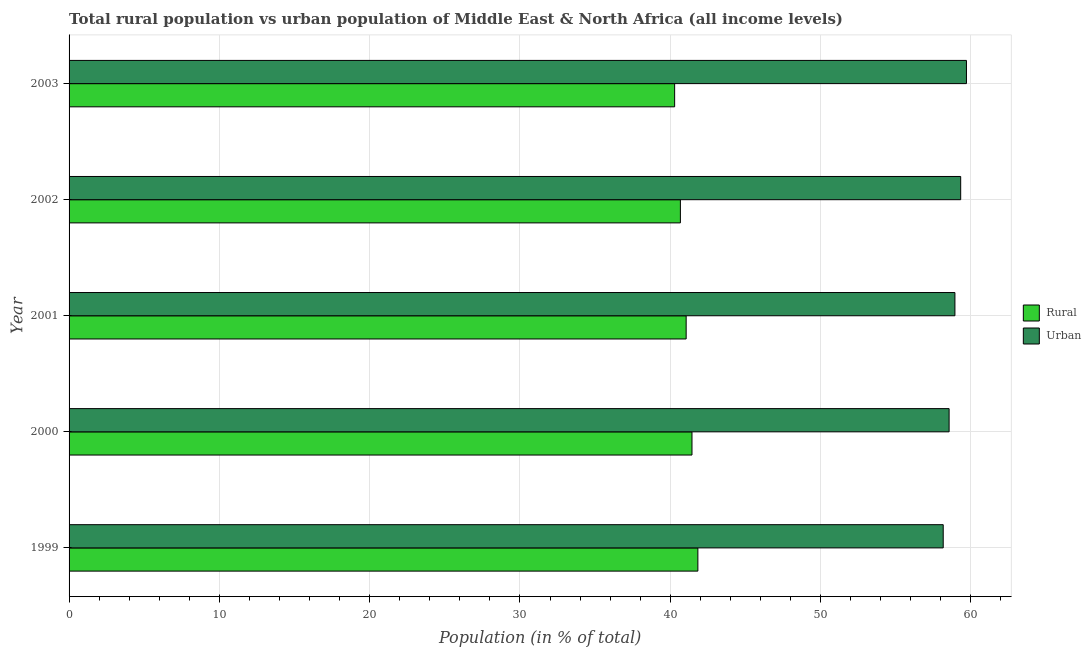How many different coloured bars are there?
Your answer should be compact. 2. How many groups of bars are there?
Your response must be concise. 5. Are the number of bars per tick equal to the number of legend labels?
Make the answer very short. Yes. Are the number of bars on each tick of the Y-axis equal?
Your answer should be compact. Yes. What is the rural population in 1999?
Provide a succinct answer. 41.84. Across all years, what is the maximum rural population?
Provide a succinct answer. 41.84. Across all years, what is the minimum urban population?
Your response must be concise. 58.16. In which year was the rural population maximum?
Offer a very short reply. 1999. In which year was the urban population minimum?
Offer a terse response. 1999. What is the total rural population in the graph?
Keep it short and to the point. 205.31. What is the difference between the rural population in 1999 and that in 2001?
Your answer should be compact. 0.78. What is the difference between the rural population in 1999 and the urban population in 2003?
Offer a very short reply. -17.87. What is the average urban population per year?
Your response must be concise. 58.94. In the year 2000, what is the difference between the rural population and urban population?
Your answer should be very brief. -17.11. What is the ratio of the urban population in 1999 to that in 2003?
Make the answer very short. 0.97. What is the difference between the highest and the second highest rural population?
Keep it short and to the point. 0.39. What is the difference between the highest and the lowest rural population?
Your response must be concise. 1.55. In how many years, is the urban population greater than the average urban population taken over all years?
Ensure brevity in your answer.  3. Is the sum of the urban population in 2000 and 2003 greater than the maximum rural population across all years?
Your response must be concise. Yes. What does the 1st bar from the top in 1999 represents?
Your answer should be very brief. Urban. What does the 1st bar from the bottom in 2000 represents?
Offer a terse response. Rural. How many bars are there?
Provide a short and direct response. 10. Are the values on the major ticks of X-axis written in scientific E-notation?
Keep it short and to the point. No. How many legend labels are there?
Ensure brevity in your answer.  2. How are the legend labels stacked?
Your answer should be compact. Vertical. What is the title of the graph?
Give a very brief answer. Total rural population vs urban population of Middle East & North Africa (all income levels). What is the label or title of the X-axis?
Your answer should be compact. Population (in % of total). What is the label or title of the Y-axis?
Provide a short and direct response. Year. What is the Population (in % of total) in Rural in 1999?
Your answer should be very brief. 41.84. What is the Population (in % of total) in Urban in 1999?
Your answer should be compact. 58.16. What is the Population (in % of total) in Rural in 2000?
Provide a short and direct response. 41.45. What is the Population (in % of total) in Urban in 2000?
Your answer should be very brief. 58.55. What is the Population (in % of total) in Rural in 2001?
Your response must be concise. 41.06. What is the Population (in % of total) in Urban in 2001?
Keep it short and to the point. 58.94. What is the Population (in % of total) of Rural in 2002?
Make the answer very short. 40.68. What is the Population (in % of total) in Urban in 2002?
Give a very brief answer. 59.32. What is the Population (in % of total) of Rural in 2003?
Keep it short and to the point. 40.29. What is the Population (in % of total) in Urban in 2003?
Provide a short and direct response. 59.71. Across all years, what is the maximum Population (in % of total) of Rural?
Ensure brevity in your answer.  41.84. Across all years, what is the maximum Population (in % of total) in Urban?
Give a very brief answer. 59.71. Across all years, what is the minimum Population (in % of total) in Rural?
Make the answer very short. 40.29. Across all years, what is the minimum Population (in % of total) in Urban?
Your answer should be compact. 58.16. What is the total Population (in % of total) of Rural in the graph?
Your answer should be compact. 205.31. What is the total Population (in % of total) in Urban in the graph?
Ensure brevity in your answer.  294.69. What is the difference between the Population (in % of total) of Rural in 1999 and that in 2000?
Keep it short and to the point. 0.39. What is the difference between the Population (in % of total) in Urban in 1999 and that in 2000?
Your answer should be compact. -0.39. What is the difference between the Population (in % of total) in Rural in 1999 and that in 2001?
Offer a terse response. 0.78. What is the difference between the Population (in % of total) of Urban in 1999 and that in 2001?
Provide a short and direct response. -0.78. What is the difference between the Population (in % of total) in Rural in 1999 and that in 2002?
Keep it short and to the point. 1.16. What is the difference between the Population (in % of total) in Urban in 1999 and that in 2002?
Provide a short and direct response. -1.16. What is the difference between the Population (in % of total) of Rural in 1999 and that in 2003?
Give a very brief answer. 1.55. What is the difference between the Population (in % of total) in Urban in 1999 and that in 2003?
Provide a succinct answer. -1.55. What is the difference between the Population (in % of total) of Rural in 2000 and that in 2001?
Give a very brief answer. 0.39. What is the difference between the Population (in % of total) in Urban in 2000 and that in 2001?
Your response must be concise. -0.39. What is the difference between the Population (in % of total) in Rural in 2000 and that in 2002?
Your answer should be very brief. 0.77. What is the difference between the Population (in % of total) of Urban in 2000 and that in 2002?
Provide a succinct answer. -0.77. What is the difference between the Population (in % of total) in Rural in 2000 and that in 2003?
Your answer should be very brief. 1.15. What is the difference between the Population (in % of total) in Urban in 2000 and that in 2003?
Your answer should be very brief. -1.15. What is the difference between the Population (in % of total) in Rural in 2001 and that in 2002?
Make the answer very short. 0.38. What is the difference between the Population (in % of total) of Urban in 2001 and that in 2002?
Your answer should be compact. -0.38. What is the difference between the Population (in % of total) of Rural in 2001 and that in 2003?
Offer a terse response. 0.77. What is the difference between the Population (in % of total) of Urban in 2001 and that in 2003?
Offer a terse response. -0.77. What is the difference between the Population (in % of total) in Rural in 2002 and that in 2003?
Offer a terse response. 0.38. What is the difference between the Population (in % of total) of Urban in 2002 and that in 2003?
Keep it short and to the point. -0.38. What is the difference between the Population (in % of total) in Rural in 1999 and the Population (in % of total) in Urban in 2000?
Offer a very short reply. -16.72. What is the difference between the Population (in % of total) of Rural in 1999 and the Population (in % of total) of Urban in 2001?
Keep it short and to the point. -17.1. What is the difference between the Population (in % of total) of Rural in 1999 and the Population (in % of total) of Urban in 2002?
Give a very brief answer. -17.49. What is the difference between the Population (in % of total) of Rural in 1999 and the Population (in % of total) of Urban in 2003?
Provide a succinct answer. -17.87. What is the difference between the Population (in % of total) in Rural in 2000 and the Population (in % of total) in Urban in 2001?
Offer a very short reply. -17.5. What is the difference between the Population (in % of total) in Rural in 2000 and the Population (in % of total) in Urban in 2002?
Your answer should be very brief. -17.88. What is the difference between the Population (in % of total) of Rural in 2000 and the Population (in % of total) of Urban in 2003?
Make the answer very short. -18.26. What is the difference between the Population (in % of total) in Rural in 2001 and the Population (in % of total) in Urban in 2002?
Provide a succinct answer. -18.27. What is the difference between the Population (in % of total) of Rural in 2001 and the Population (in % of total) of Urban in 2003?
Your answer should be compact. -18.65. What is the difference between the Population (in % of total) of Rural in 2002 and the Population (in % of total) of Urban in 2003?
Give a very brief answer. -19.03. What is the average Population (in % of total) in Rural per year?
Provide a succinct answer. 41.06. What is the average Population (in % of total) in Urban per year?
Your answer should be compact. 58.94. In the year 1999, what is the difference between the Population (in % of total) of Rural and Population (in % of total) of Urban?
Provide a succinct answer. -16.32. In the year 2000, what is the difference between the Population (in % of total) in Rural and Population (in % of total) in Urban?
Offer a terse response. -17.11. In the year 2001, what is the difference between the Population (in % of total) of Rural and Population (in % of total) of Urban?
Provide a succinct answer. -17.88. In the year 2002, what is the difference between the Population (in % of total) of Rural and Population (in % of total) of Urban?
Provide a succinct answer. -18.65. In the year 2003, what is the difference between the Population (in % of total) of Rural and Population (in % of total) of Urban?
Keep it short and to the point. -19.42. What is the ratio of the Population (in % of total) of Rural in 1999 to that in 2000?
Your answer should be compact. 1.01. What is the ratio of the Population (in % of total) in Rural in 1999 to that in 2002?
Your answer should be very brief. 1.03. What is the ratio of the Population (in % of total) in Urban in 1999 to that in 2002?
Offer a very short reply. 0.98. What is the ratio of the Population (in % of total) of Rural in 1999 to that in 2003?
Ensure brevity in your answer.  1.04. What is the ratio of the Population (in % of total) in Urban in 1999 to that in 2003?
Provide a succinct answer. 0.97. What is the ratio of the Population (in % of total) of Rural in 2000 to that in 2001?
Provide a succinct answer. 1.01. What is the ratio of the Population (in % of total) of Rural in 2000 to that in 2002?
Provide a succinct answer. 1.02. What is the ratio of the Population (in % of total) in Rural in 2000 to that in 2003?
Your response must be concise. 1.03. What is the ratio of the Population (in % of total) in Urban in 2000 to that in 2003?
Ensure brevity in your answer.  0.98. What is the ratio of the Population (in % of total) in Rural in 2001 to that in 2002?
Offer a terse response. 1.01. What is the ratio of the Population (in % of total) of Urban in 2001 to that in 2003?
Offer a very short reply. 0.99. What is the ratio of the Population (in % of total) in Rural in 2002 to that in 2003?
Your response must be concise. 1.01. What is the difference between the highest and the second highest Population (in % of total) of Rural?
Provide a short and direct response. 0.39. What is the difference between the highest and the second highest Population (in % of total) in Urban?
Provide a succinct answer. 0.38. What is the difference between the highest and the lowest Population (in % of total) of Rural?
Ensure brevity in your answer.  1.55. What is the difference between the highest and the lowest Population (in % of total) in Urban?
Offer a terse response. 1.55. 